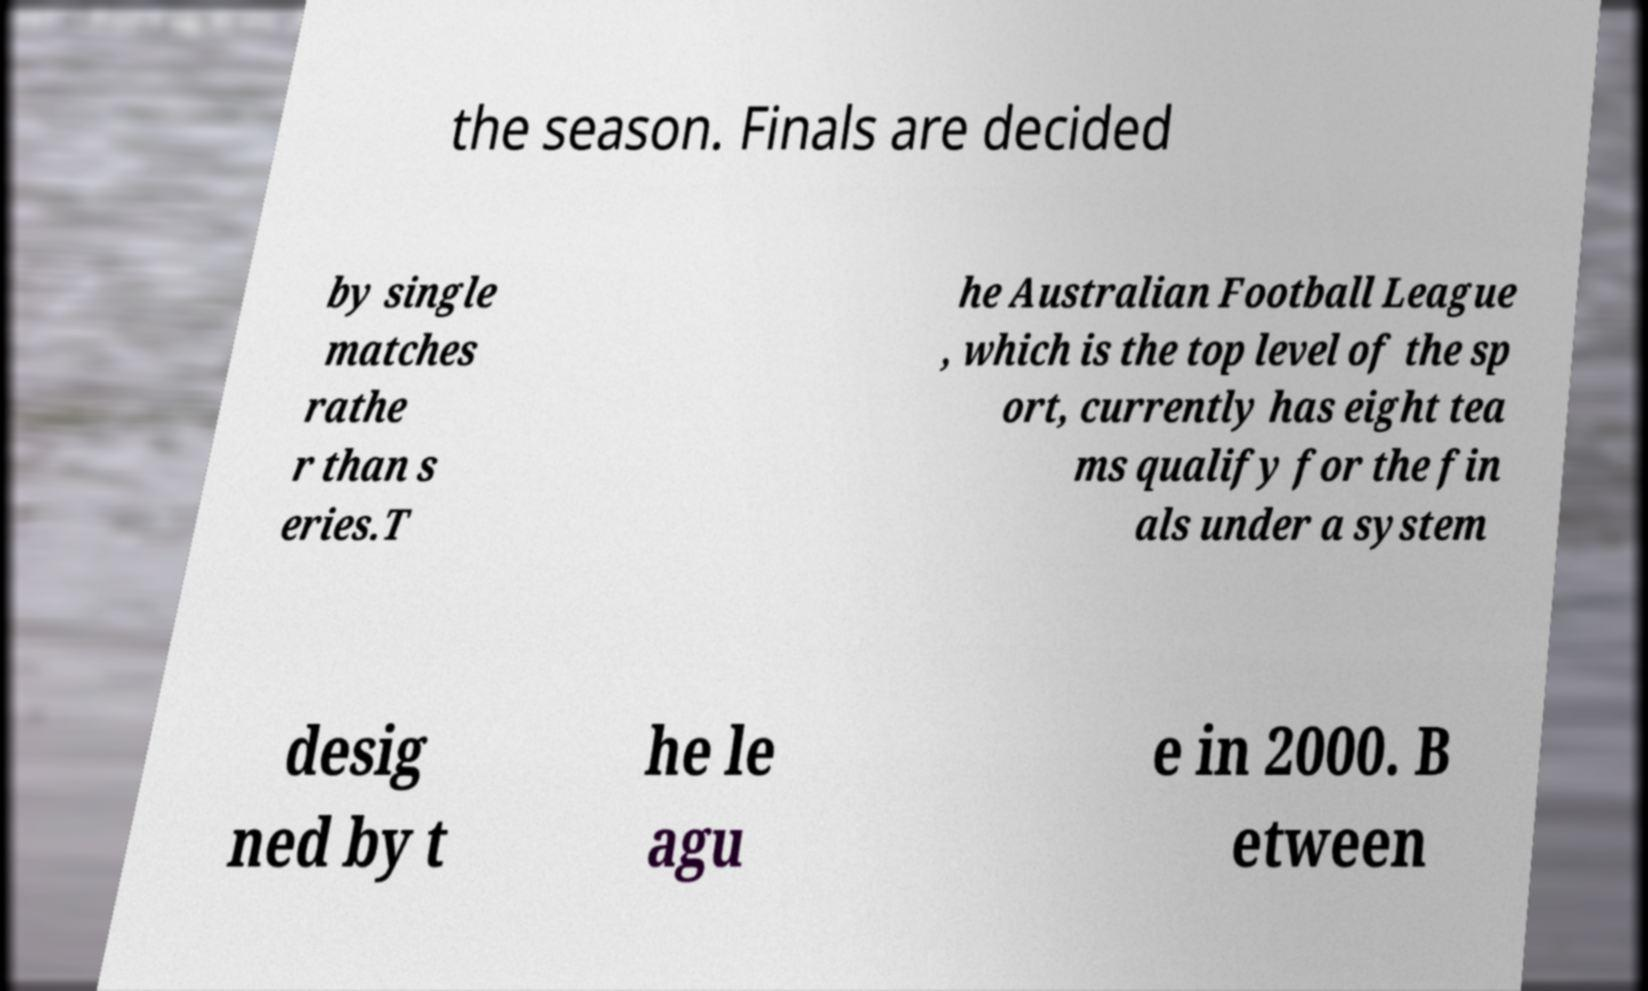Can you read and provide the text displayed in the image?This photo seems to have some interesting text. Can you extract and type it out for me? the season. Finals are decided by single matches rathe r than s eries.T he Australian Football League , which is the top level of the sp ort, currently has eight tea ms qualify for the fin als under a system desig ned by t he le agu e in 2000. B etween 